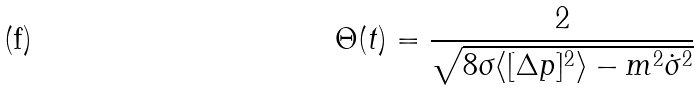<formula> <loc_0><loc_0><loc_500><loc_500>\Theta ( t ) = \frac { 2 } { \sqrt { 8 \sigma \langle [ \Delta p ] ^ { 2 } \rangle - m ^ { 2 } \dot { \sigma } ^ { 2 } } }</formula> 